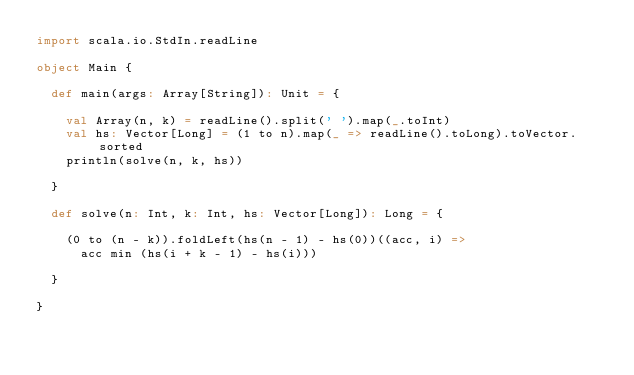<code> <loc_0><loc_0><loc_500><loc_500><_Scala_>import scala.io.StdIn.readLine

object Main {

  def main(args: Array[String]): Unit = {

    val Array(n, k) = readLine().split(' ').map(_.toInt)
    val hs: Vector[Long] = (1 to n).map(_ => readLine().toLong).toVector.sorted
    println(solve(n, k, hs))

  }

  def solve(n: Int, k: Int, hs: Vector[Long]): Long = {

    (0 to (n - k)).foldLeft(hs(n - 1) - hs(0))((acc, i) =>
      acc min (hs(i + k - 1) - hs(i)))

  }

}
</code> 